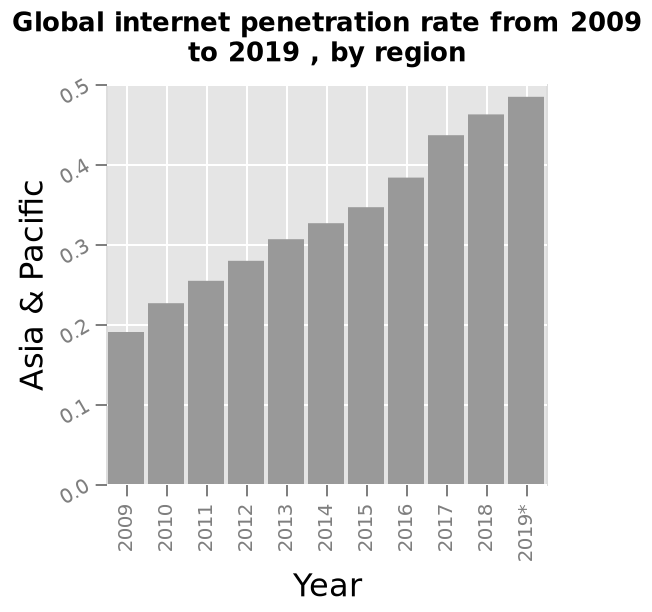<image>
How would you describe the trend of the penetration rate over time? The trend of the penetration rate over time is positive. 